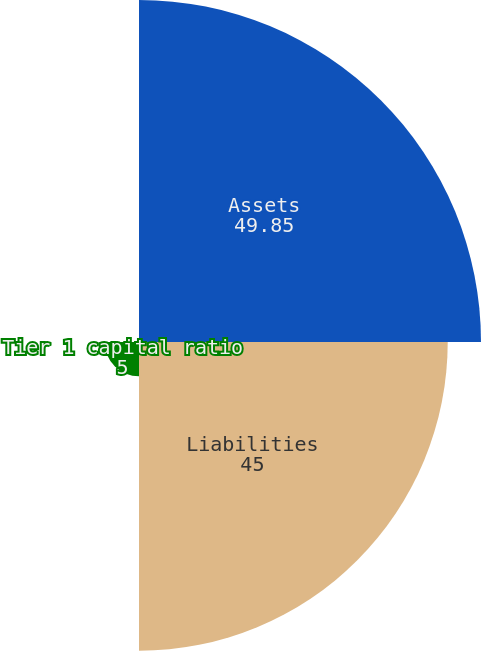Convert chart. <chart><loc_0><loc_0><loc_500><loc_500><pie_chart><fcel>Assets<fcel>Liabilities<fcel>Tier 1 capital ratio<fcel>Tier 1 leverage ratio<nl><fcel>49.85%<fcel>45.0%<fcel>5.0%<fcel>0.15%<nl></chart> 